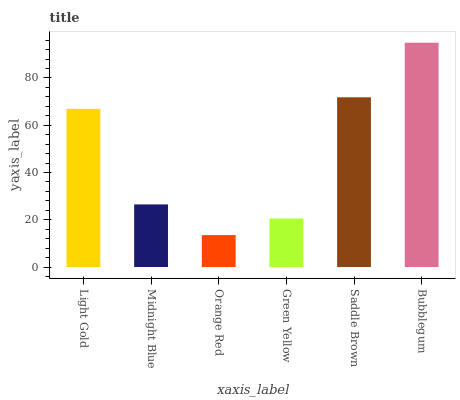Is Orange Red the minimum?
Answer yes or no. Yes. Is Bubblegum the maximum?
Answer yes or no. Yes. Is Midnight Blue the minimum?
Answer yes or no. No. Is Midnight Blue the maximum?
Answer yes or no. No. Is Light Gold greater than Midnight Blue?
Answer yes or no. Yes. Is Midnight Blue less than Light Gold?
Answer yes or no. Yes. Is Midnight Blue greater than Light Gold?
Answer yes or no. No. Is Light Gold less than Midnight Blue?
Answer yes or no. No. Is Light Gold the high median?
Answer yes or no. Yes. Is Midnight Blue the low median?
Answer yes or no. Yes. Is Bubblegum the high median?
Answer yes or no. No. Is Light Gold the low median?
Answer yes or no. No. 